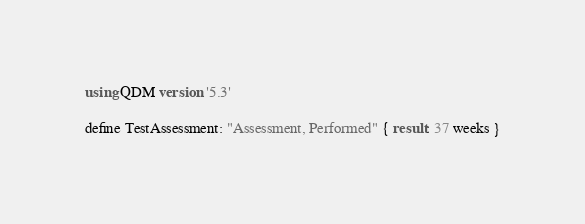<code> <loc_0><loc_0><loc_500><loc_500><_SQL_>using QDM version '5.3'

define TestAssessment: "Assessment, Performed" { result: 37 weeks }
</code> 